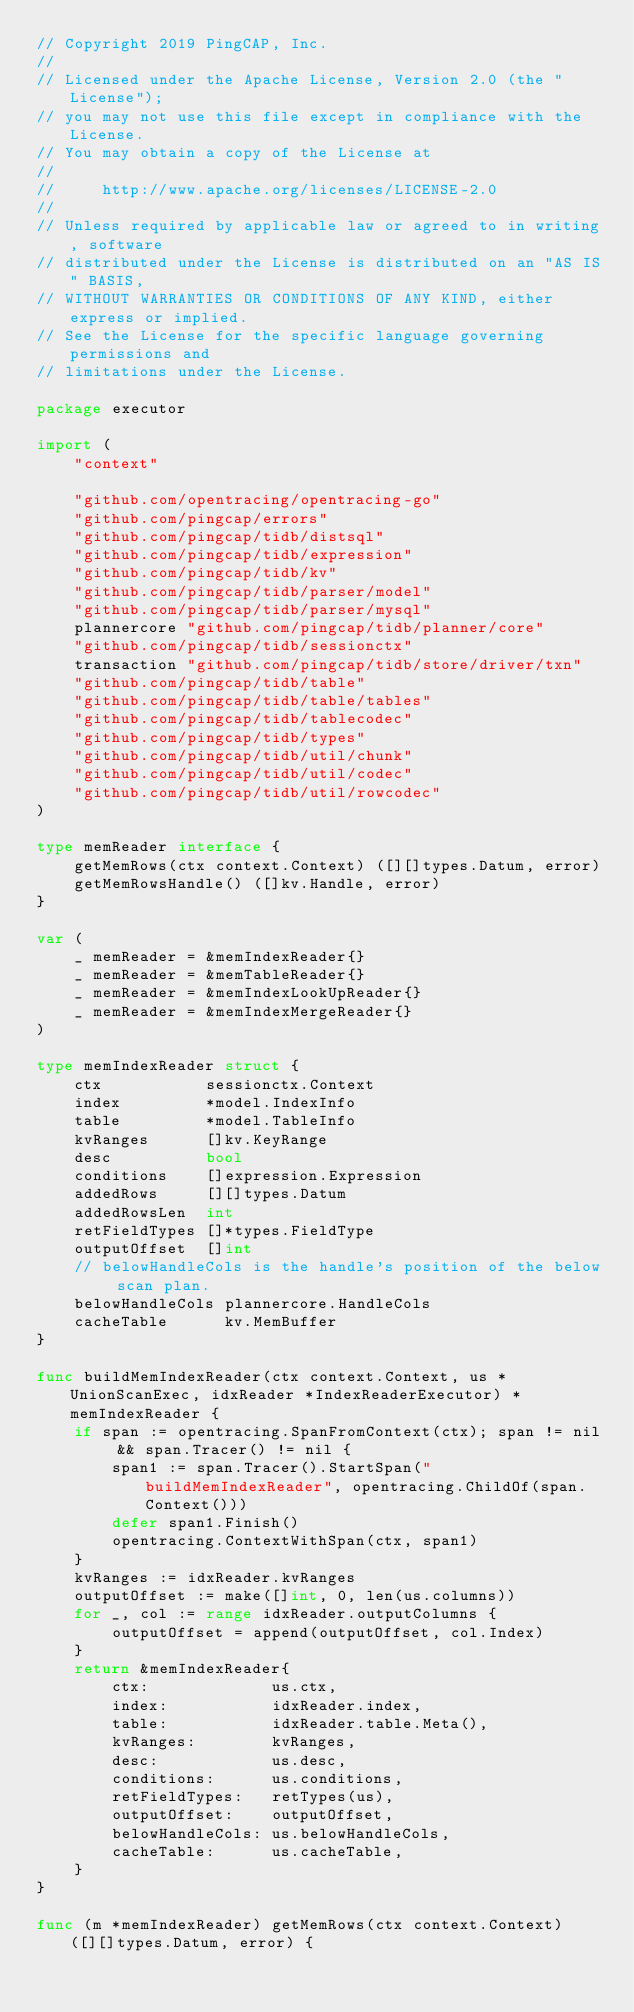<code> <loc_0><loc_0><loc_500><loc_500><_Go_>// Copyright 2019 PingCAP, Inc.
//
// Licensed under the Apache License, Version 2.0 (the "License");
// you may not use this file except in compliance with the License.
// You may obtain a copy of the License at
//
//     http://www.apache.org/licenses/LICENSE-2.0
//
// Unless required by applicable law or agreed to in writing, software
// distributed under the License is distributed on an "AS IS" BASIS,
// WITHOUT WARRANTIES OR CONDITIONS OF ANY KIND, either express or implied.
// See the License for the specific language governing permissions and
// limitations under the License.

package executor

import (
	"context"

	"github.com/opentracing/opentracing-go"
	"github.com/pingcap/errors"
	"github.com/pingcap/tidb/distsql"
	"github.com/pingcap/tidb/expression"
	"github.com/pingcap/tidb/kv"
	"github.com/pingcap/tidb/parser/model"
	"github.com/pingcap/tidb/parser/mysql"
	plannercore "github.com/pingcap/tidb/planner/core"
	"github.com/pingcap/tidb/sessionctx"
	transaction "github.com/pingcap/tidb/store/driver/txn"
	"github.com/pingcap/tidb/table"
	"github.com/pingcap/tidb/table/tables"
	"github.com/pingcap/tidb/tablecodec"
	"github.com/pingcap/tidb/types"
	"github.com/pingcap/tidb/util/chunk"
	"github.com/pingcap/tidb/util/codec"
	"github.com/pingcap/tidb/util/rowcodec"
)

type memReader interface {
	getMemRows(ctx context.Context) ([][]types.Datum, error)
	getMemRowsHandle() ([]kv.Handle, error)
}

var (
	_ memReader = &memIndexReader{}
	_ memReader = &memTableReader{}
	_ memReader = &memIndexLookUpReader{}
	_ memReader = &memIndexMergeReader{}
)

type memIndexReader struct {
	ctx           sessionctx.Context
	index         *model.IndexInfo
	table         *model.TableInfo
	kvRanges      []kv.KeyRange
	desc          bool
	conditions    []expression.Expression
	addedRows     [][]types.Datum
	addedRowsLen  int
	retFieldTypes []*types.FieldType
	outputOffset  []int
	// belowHandleCols is the handle's position of the below scan plan.
	belowHandleCols plannercore.HandleCols
	cacheTable      kv.MemBuffer
}

func buildMemIndexReader(ctx context.Context, us *UnionScanExec, idxReader *IndexReaderExecutor) *memIndexReader {
	if span := opentracing.SpanFromContext(ctx); span != nil && span.Tracer() != nil {
		span1 := span.Tracer().StartSpan("buildMemIndexReader", opentracing.ChildOf(span.Context()))
		defer span1.Finish()
		opentracing.ContextWithSpan(ctx, span1)
	}
	kvRanges := idxReader.kvRanges
	outputOffset := make([]int, 0, len(us.columns))
	for _, col := range idxReader.outputColumns {
		outputOffset = append(outputOffset, col.Index)
	}
	return &memIndexReader{
		ctx:             us.ctx,
		index:           idxReader.index,
		table:           idxReader.table.Meta(),
		kvRanges:        kvRanges,
		desc:            us.desc,
		conditions:      us.conditions,
		retFieldTypes:   retTypes(us),
		outputOffset:    outputOffset,
		belowHandleCols: us.belowHandleCols,
		cacheTable:      us.cacheTable,
	}
}

func (m *memIndexReader) getMemRows(ctx context.Context) ([][]types.Datum, error) {</code> 